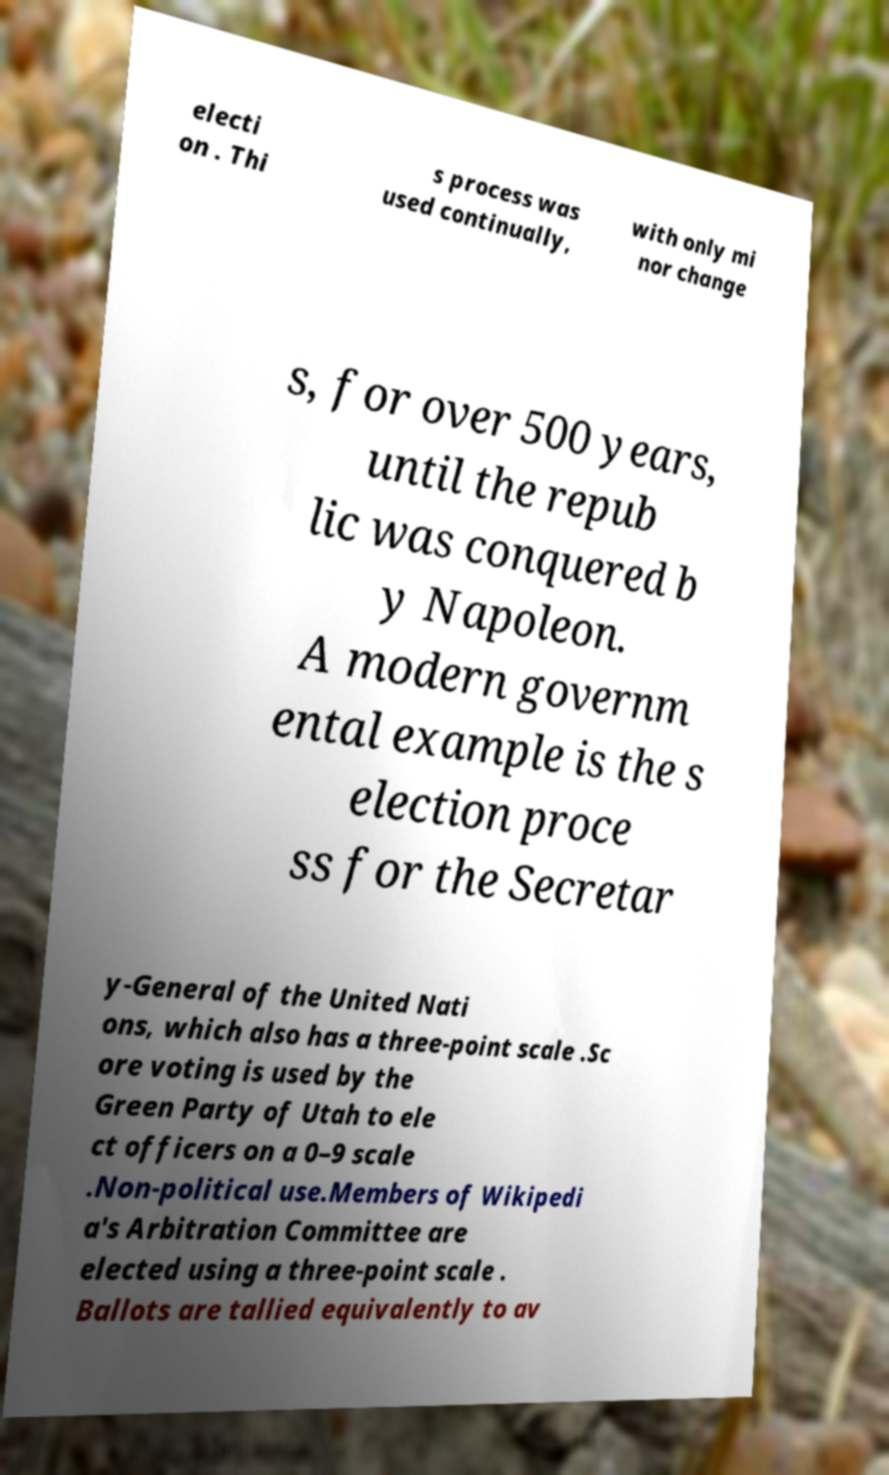Please read and relay the text visible in this image. What does it say? electi on . Thi s process was used continually, with only mi nor change s, for over 500 years, until the repub lic was conquered b y Napoleon. A modern governm ental example is the s election proce ss for the Secretar y-General of the United Nati ons, which also has a three-point scale .Sc ore voting is used by the Green Party of Utah to ele ct officers on a 0–9 scale .Non-political use.Members of Wikipedi a's Arbitration Committee are elected using a three-point scale . Ballots are tallied equivalently to av 